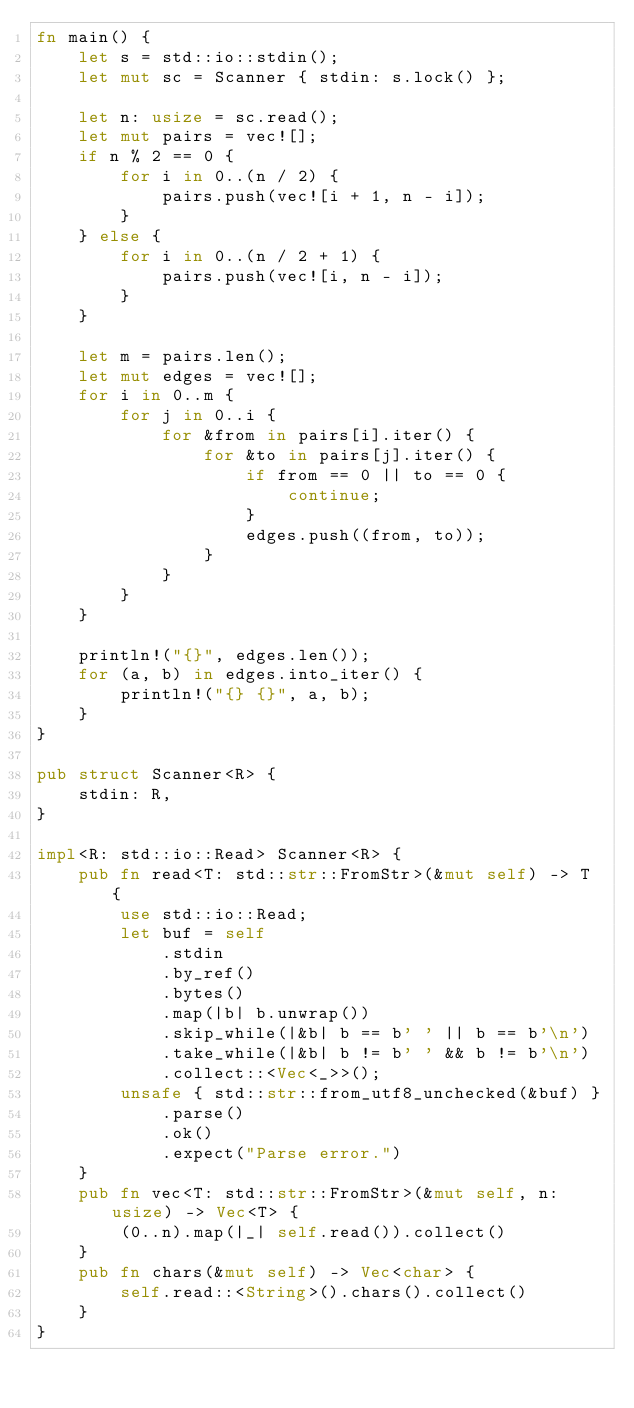Convert code to text. <code><loc_0><loc_0><loc_500><loc_500><_Rust_>fn main() {
    let s = std::io::stdin();
    let mut sc = Scanner { stdin: s.lock() };

    let n: usize = sc.read();
    let mut pairs = vec![];
    if n % 2 == 0 {
        for i in 0..(n / 2) {
            pairs.push(vec![i + 1, n - i]);
        }
    } else {
        for i in 0..(n / 2 + 1) {
            pairs.push(vec![i, n - i]);
        }
    }

    let m = pairs.len();
    let mut edges = vec![];
    for i in 0..m {
        for j in 0..i {
            for &from in pairs[i].iter() {
                for &to in pairs[j].iter() {
                    if from == 0 || to == 0 {
                        continue;
                    }
                    edges.push((from, to));
                }
            }
        }
    }

    println!("{}", edges.len());
    for (a, b) in edges.into_iter() {
        println!("{} {}", a, b);
    }
}

pub struct Scanner<R> {
    stdin: R,
}

impl<R: std::io::Read> Scanner<R> {
    pub fn read<T: std::str::FromStr>(&mut self) -> T {
        use std::io::Read;
        let buf = self
            .stdin
            .by_ref()
            .bytes()
            .map(|b| b.unwrap())
            .skip_while(|&b| b == b' ' || b == b'\n')
            .take_while(|&b| b != b' ' && b != b'\n')
            .collect::<Vec<_>>();
        unsafe { std::str::from_utf8_unchecked(&buf) }
            .parse()
            .ok()
            .expect("Parse error.")
    }
    pub fn vec<T: std::str::FromStr>(&mut self, n: usize) -> Vec<T> {
        (0..n).map(|_| self.read()).collect()
    }
    pub fn chars(&mut self) -> Vec<char> {
        self.read::<String>().chars().collect()
    }
}
</code> 